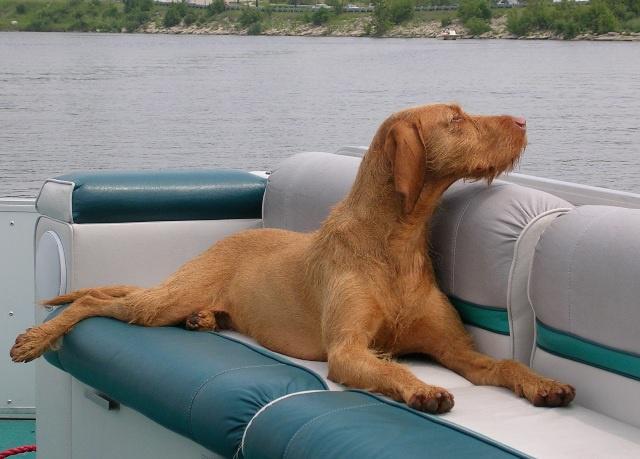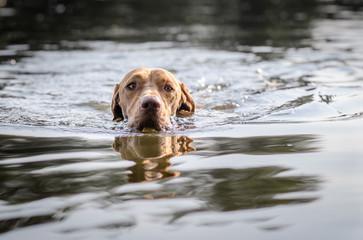The first image is the image on the left, the second image is the image on the right. Considering the images on both sides, is "Exactly one dog is standing in water." valid? Answer yes or no. No. The first image is the image on the left, the second image is the image on the right. Assess this claim about the two images: "In the left image there is a brown dog sitting on the ground.". Correct or not? Answer yes or no. No. 